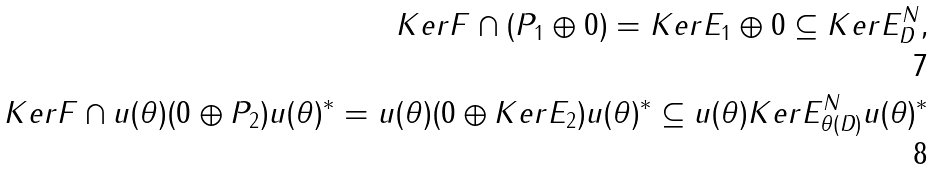Convert formula to latex. <formula><loc_0><loc_0><loc_500><loc_500>K e r F \cap ( P _ { 1 } \oplus 0 ) = K e r E _ { 1 } \oplus 0 \subseteq K e r E _ { D } ^ { N } , \\ K e r F \cap u ( \theta ) ( 0 \oplus P _ { 2 } ) u ( \theta ) ^ { * } = u ( \theta ) ( 0 \oplus K e r E _ { 2 } ) u ( \theta ) ^ { * } \subseteq u ( \theta ) K e r E _ { \theta ( D ) } ^ { N } u ( \theta ) ^ { * }</formula> 